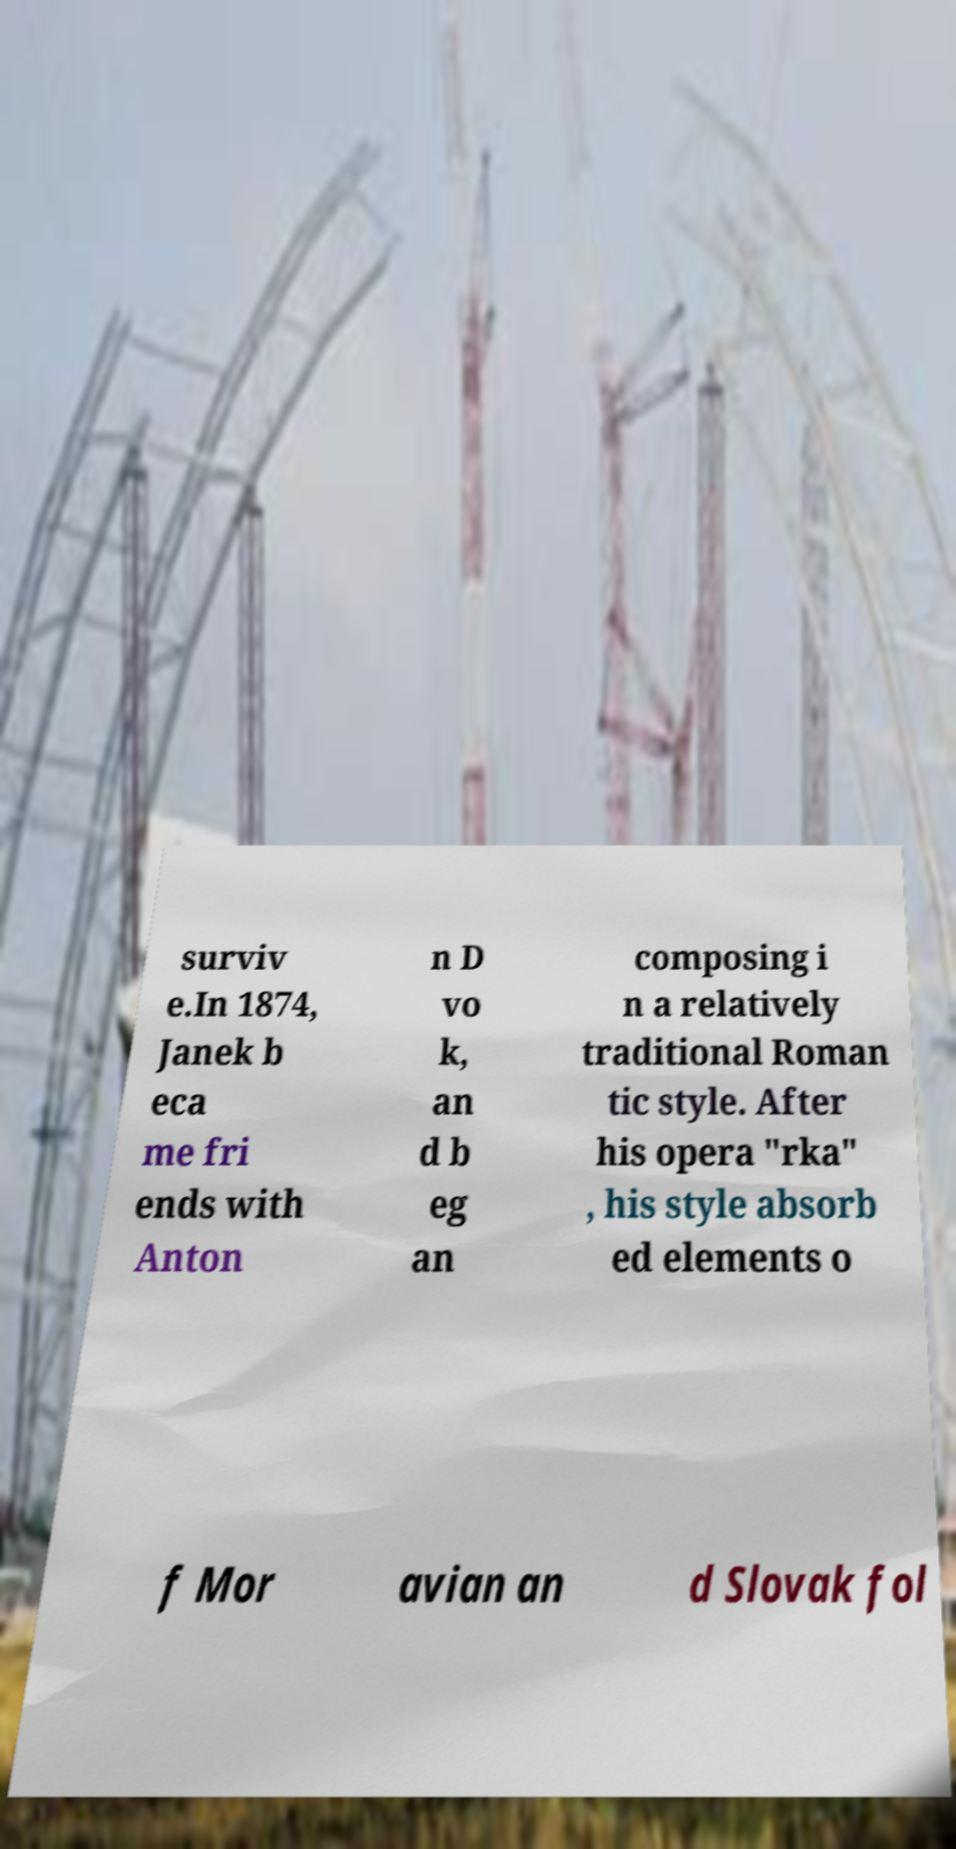There's text embedded in this image that I need extracted. Can you transcribe it verbatim? surviv e.In 1874, Janek b eca me fri ends with Anton n D vo k, an d b eg an composing i n a relatively traditional Roman tic style. After his opera "rka" , his style absorb ed elements o f Mor avian an d Slovak fol 